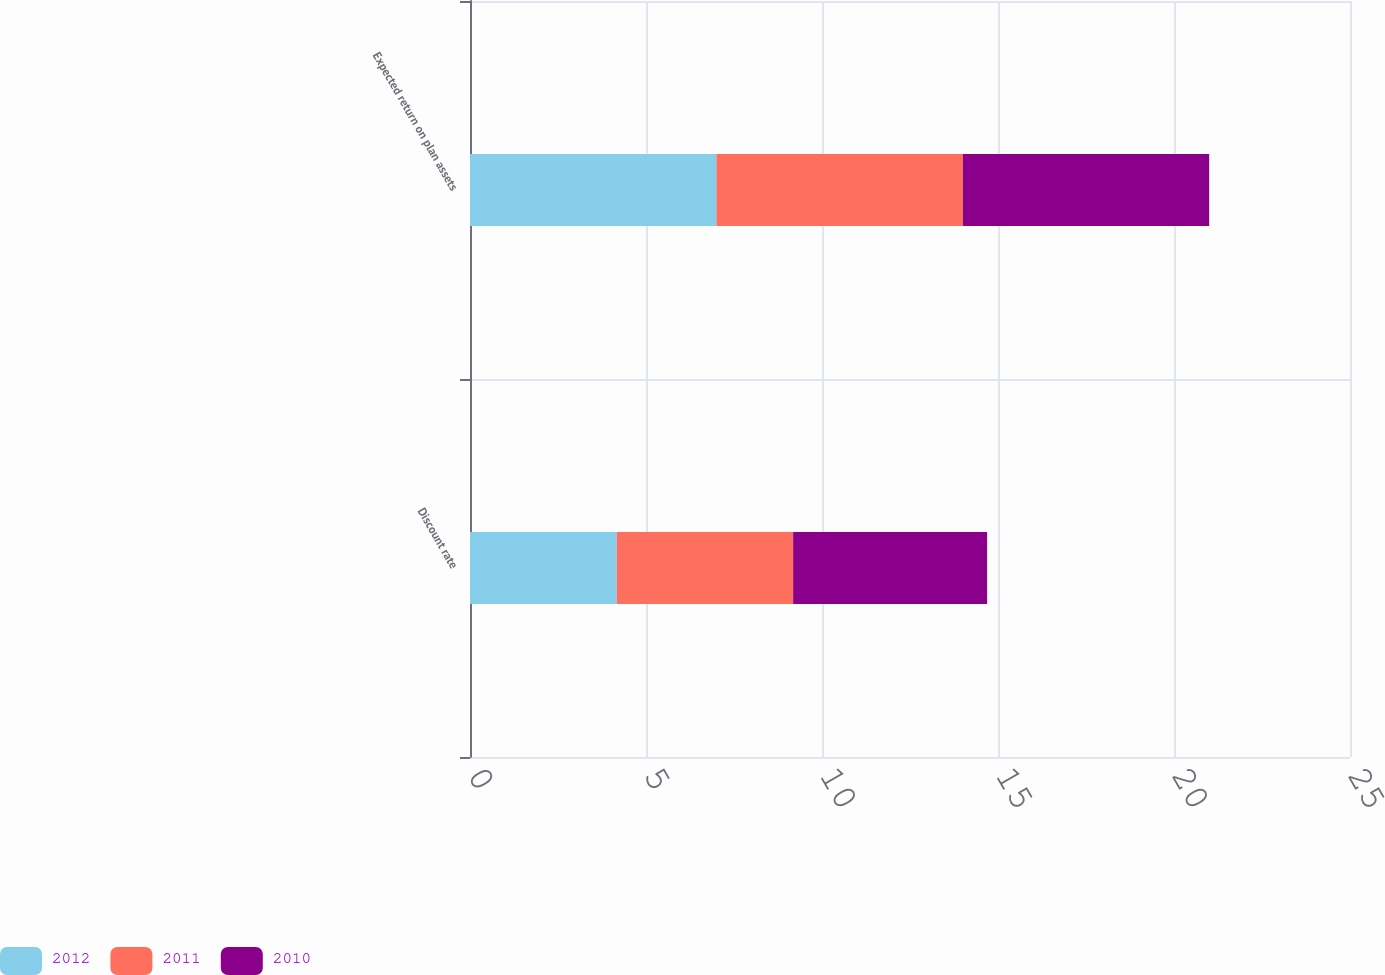<chart> <loc_0><loc_0><loc_500><loc_500><stacked_bar_chart><ecel><fcel>Discount rate<fcel>Expected return on plan assets<nl><fcel>2012<fcel>4.17<fcel>7<nl><fcel>2011<fcel>5.01<fcel>7<nl><fcel>2010<fcel>5.51<fcel>7<nl></chart> 